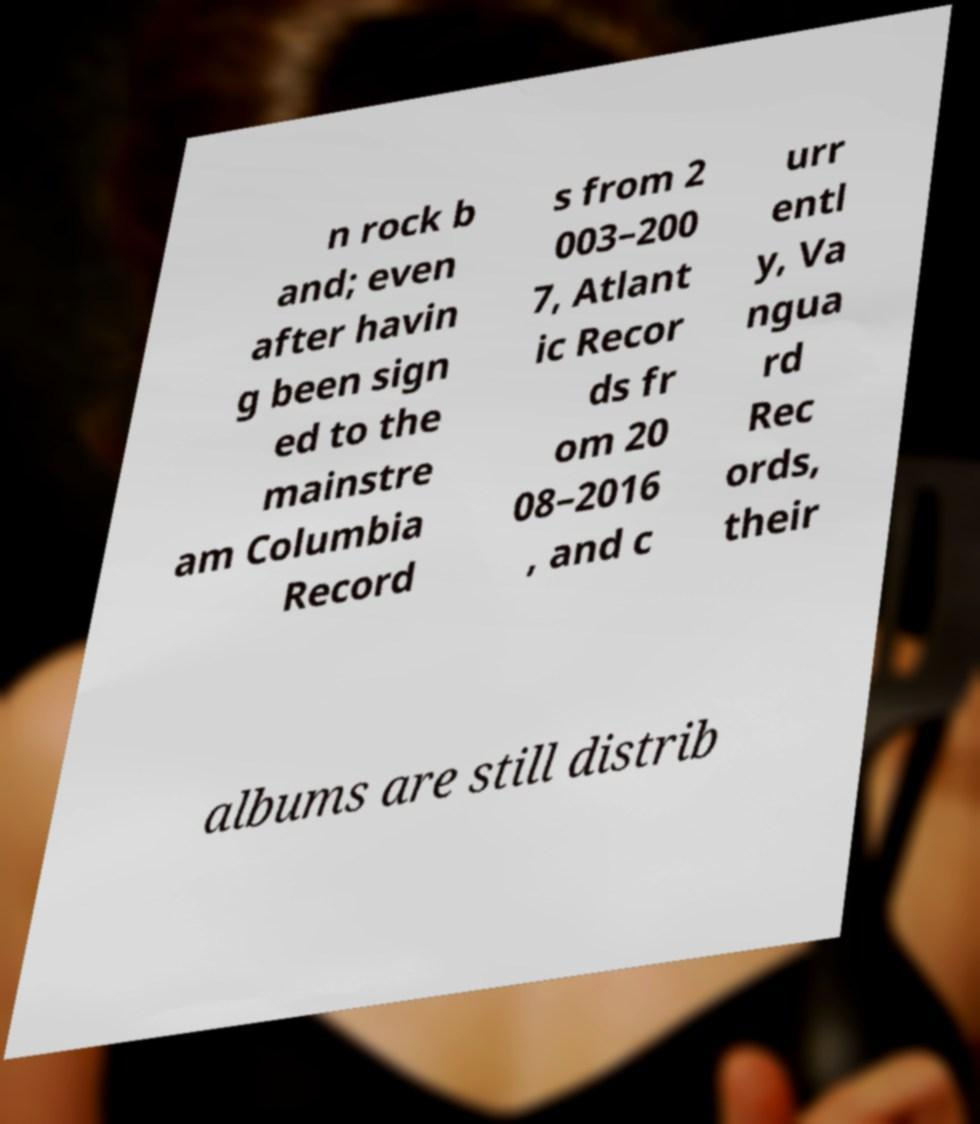I need the written content from this picture converted into text. Can you do that? n rock b and; even after havin g been sign ed to the mainstre am Columbia Record s from 2 003–200 7, Atlant ic Recor ds fr om 20 08–2016 , and c urr entl y, Va ngua rd Rec ords, their albums are still distrib 